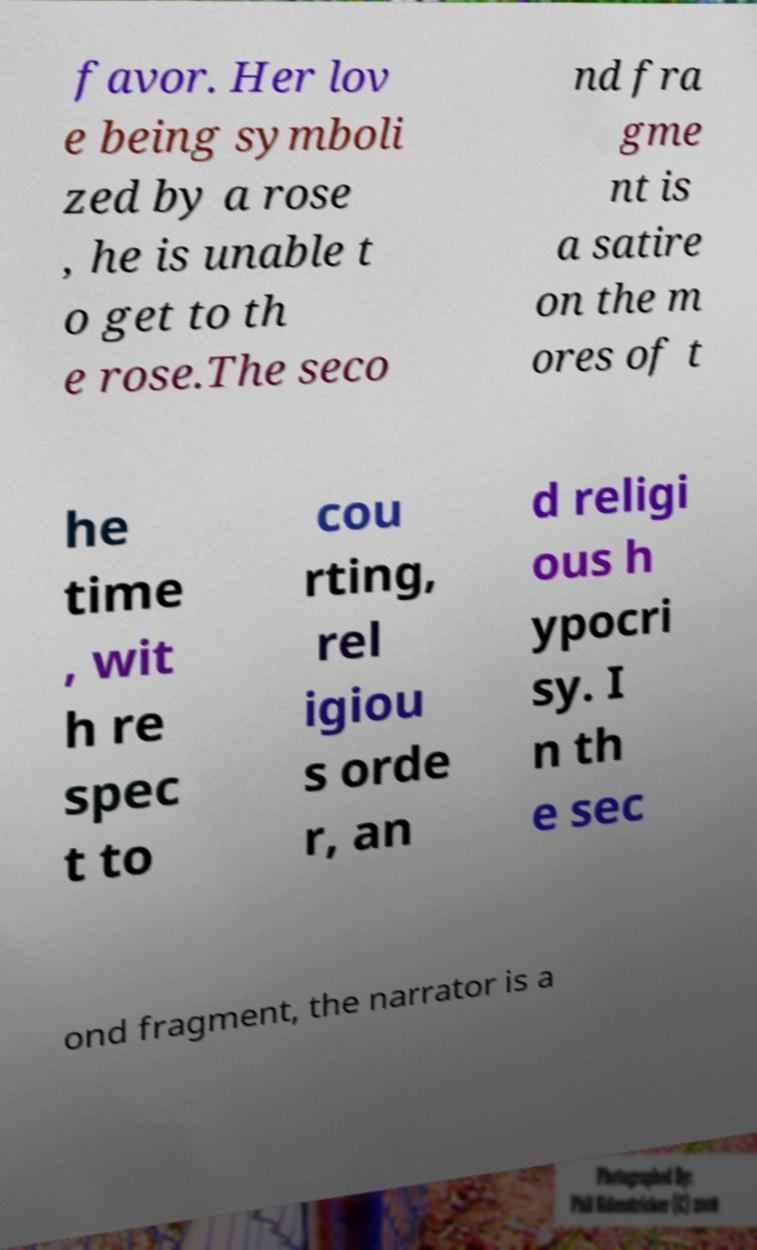Please identify and transcribe the text found in this image. favor. Her lov e being symboli zed by a rose , he is unable t o get to th e rose.The seco nd fra gme nt is a satire on the m ores of t he time , wit h re spec t to cou rting, rel igiou s orde r, an d religi ous h ypocri sy. I n th e sec ond fragment, the narrator is a 